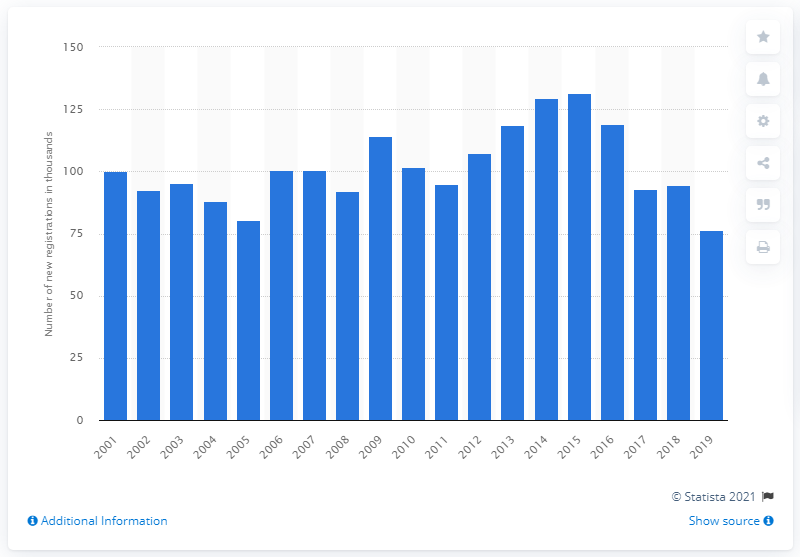Highlight a few significant elements in this photo. In 2015, a peak in sales of the Ford Fiesta was observed. 